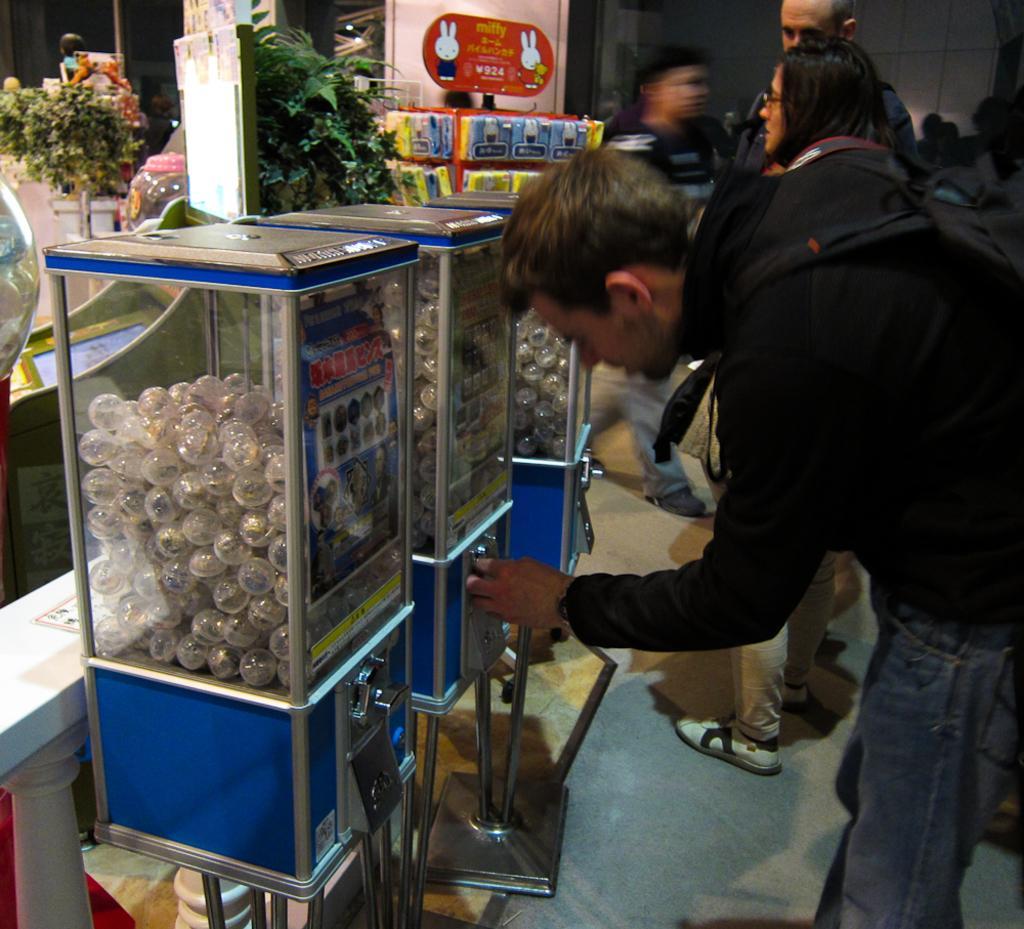Please provide a concise description of this image. In this image in the center there are persons standing. On the left side there are objects which are white in colour inside the boxes and there are plants. 